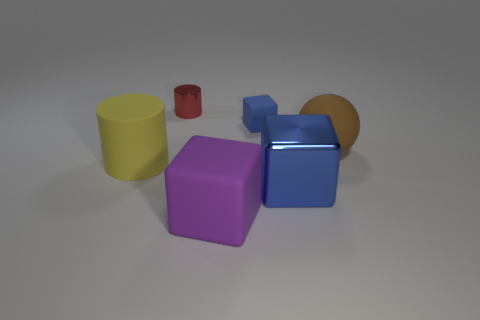There is a tiny thing left of the purple rubber object; is its color the same as the large matte cylinder? No, the small object to the left of the purple rubber cube is red, which contrasts with the large matte cylinder that is yellow. Despite their different materials and sizes, the vibrancy of the red object makes it quite distinguishable from its surroundings. 